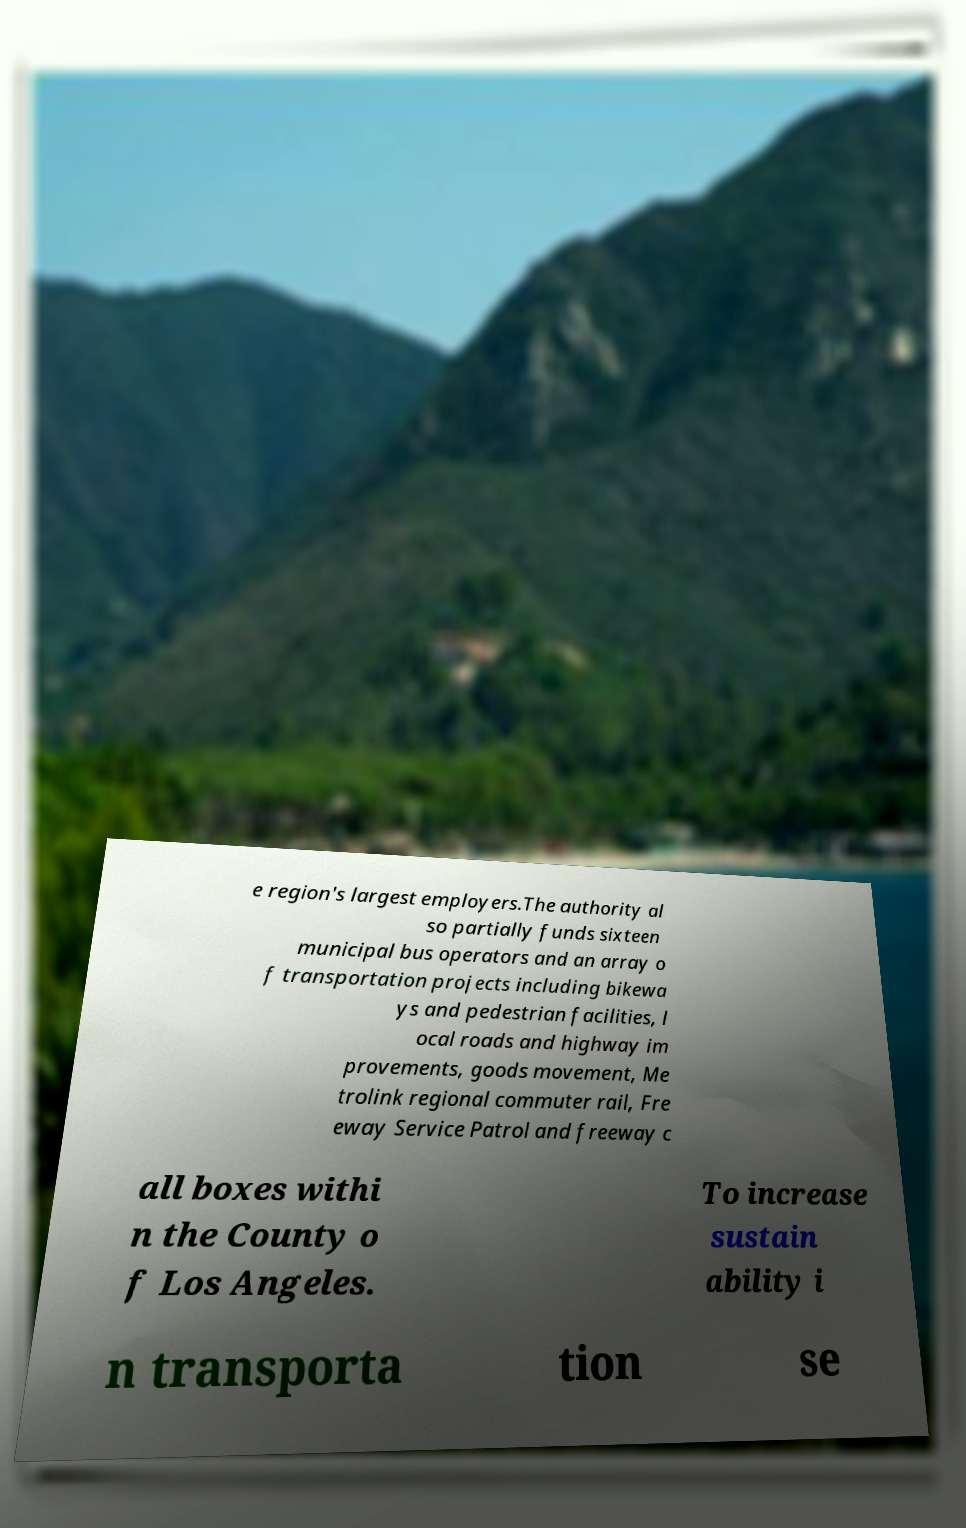What messages or text are displayed in this image? I need them in a readable, typed format. e region's largest employers.The authority al so partially funds sixteen municipal bus operators and an array o f transportation projects including bikewa ys and pedestrian facilities, l ocal roads and highway im provements, goods movement, Me trolink regional commuter rail, Fre eway Service Patrol and freeway c all boxes withi n the County o f Los Angeles. To increase sustain ability i n transporta tion se 